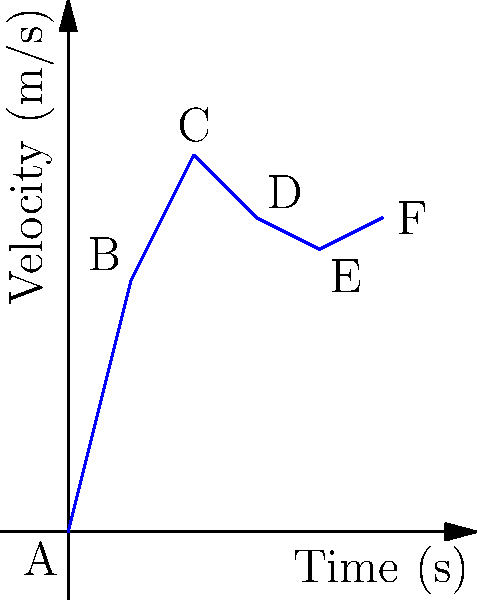In a 100-meter dash, a sprinter's velocity at different time intervals is shown in the graph above. If the sprinter has a mass of 70 kg, at which point does the sprinter have the highest kinetic energy? Calculate the maximum kinetic energy in joules. To solve this problem, we need to follow these steps:

1) Recall the formula for kinetic energy: $KE = \frac{1}{2}mv^2$

2) We know the mass (m) is constant at 70 kg. So, the kinetic energy will be highest when the velocity (v) is highest.

3) From the graph, we can see that the velocity is highest at point C, which is 12 m/s.

4) Now, let's calculate the kinetic energy at point C:

   $KE = \frac{1}{2} \times 70 \times 12^2$
   
   $KE = 35 \times 144$
   
   $KE = 5040$ joules

Therefore, the sprinter has the highest kinetic energy at point C, and the maximum kinetic energy is 5040 joules.
Answer: 5040 J at point C 